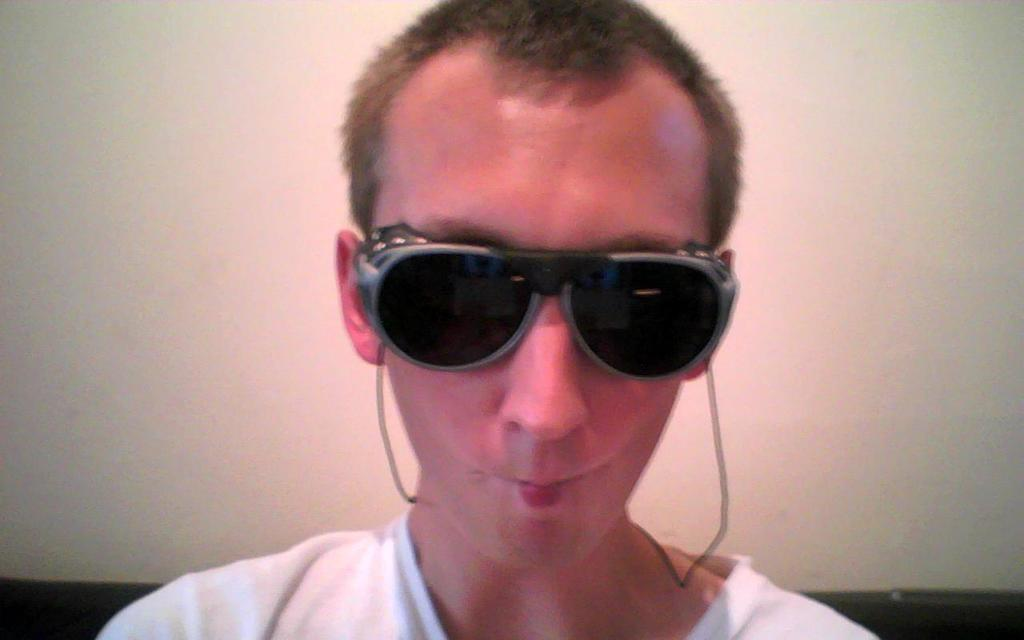Who or what is the main subject in the image? There is a person in the image. What accessory is the person wearing? The person is wearing glasses. What can be seen behind the person in the image? There is a wall in the background of the image. How many kittens are sitting on the person's lap in the image? There are no kittens present in the image. What is the weight of the plastic object on the wall in the image? There is no plastic object on the wall in the image. 